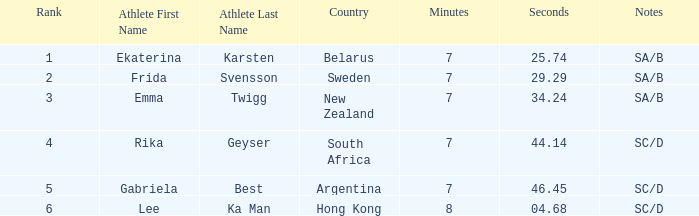Which nation is home to the athlete ekaterina karsten, having a rank under 4? Belarus. 